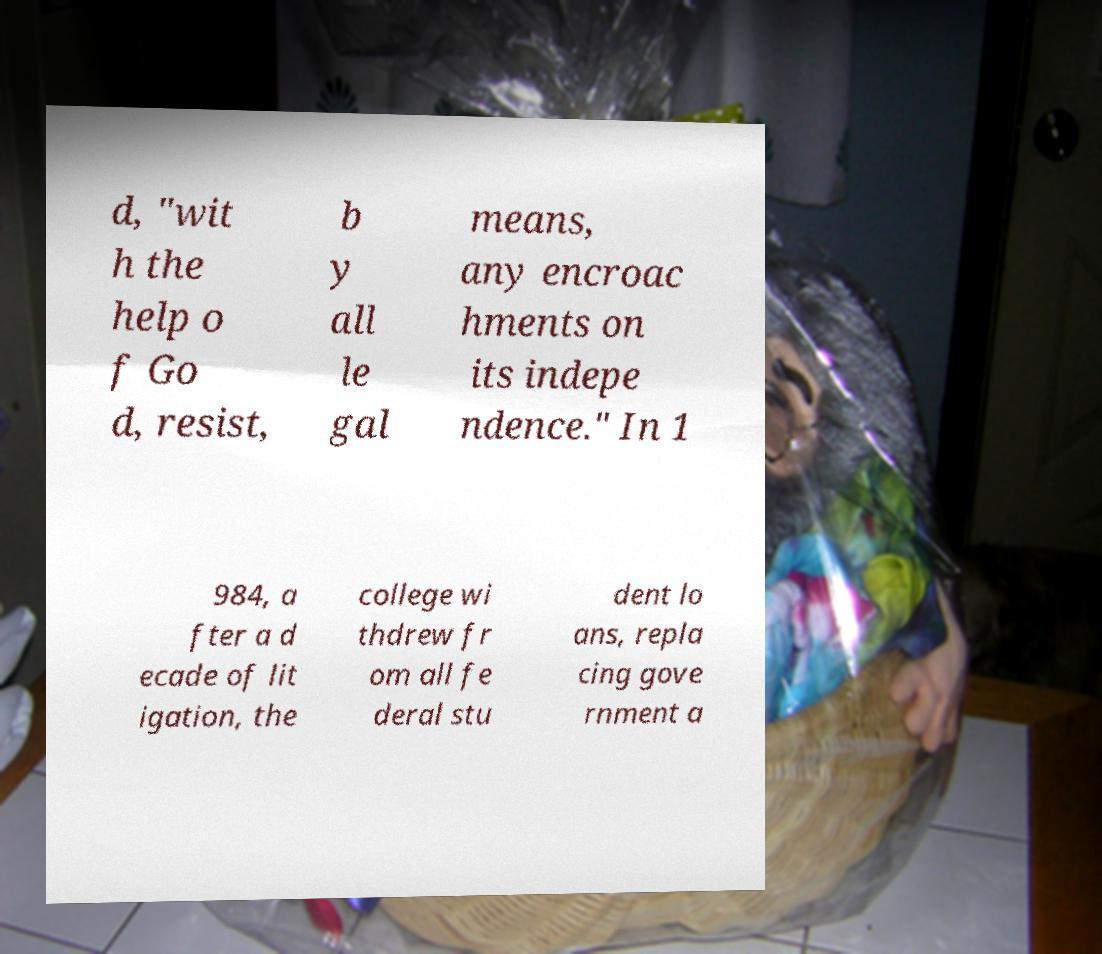Please identify and transcribe the text found in this image. d, "wit h the help o f Go d, resist, b y all le gal means, any encroac hments on its indepe ndence." In 1 984, a fter a d ecade of lit igation, the college wi thdrew fr om all fe deral stu dent lo ans, repla cing gove rnment a 